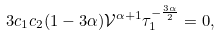Convert formula to latex. <formula><loc_0><loc_0><loc_500><loc_500>3 c _ { 1 } c _ { 2 } ( 1 - 3 \alpha ) \mathcal { V } ^ { \alpha + 1 } \tau _ { 1 } ^ { - \frac { 3 \alpha } { 2 } } = 0 ,</formula> 